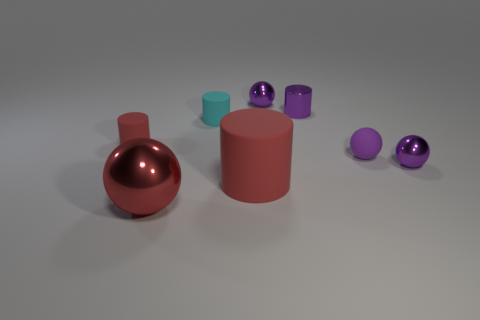There is a metallic thing that is both on the left side of the small metal cylinder and in front of the small rubber ball; what is its shape?
Your answer should be very brief. Sphere. Is there a matte ball of the same size as the cyan matte thing?
Give a very brief answer. Yes. There is a small shiny cylinder; is its color the same as the sphere behind the small purple metallic cylinder?
Your answer should be very brief. Yes. What material is the small red cylinder?
Make the answer very short. Rubber. What is the color of the matte cylinder that is on the left side of the big red shiny sphere?
Make the answer very short. Red. What number of large matte objects have the same color as the shiny cylinder?
Offer a terse response. 0. What number of small purple balls are behind the cyan cylinder and on the right side of the purple rubber sphere?
Offer a very short reply. 0. There is a cyan matte thing that is the same size as the purple shiny cylinder; what is its shape?
Provide a succinct answer. Cylinder. The red ball has what size?
Offer a very short reply. Large. There is a big red object that is in front of the red cylinder in front of the small matte cylinder that is in front of the cyan cylinder; what is its material?
Your response must be concise. Metal. 